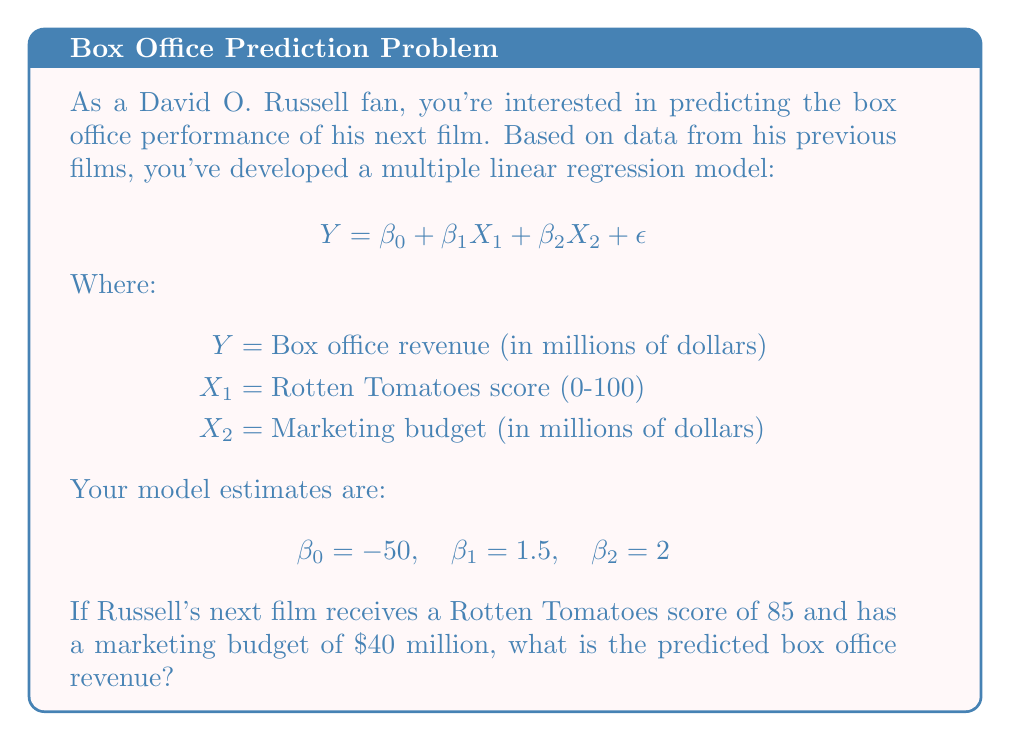Show me your answer to this math problem. To solve this problem, we'll use the given multiple linear regression model and substitute the known values:

1. Recall the model equation:
   $$Y = \beta_0 + \beta_1X_1 + \beta_2X_2 + \epsilon$$

2. We're given the following estimates:
   $\beta_0 = -50$
   $\beta_1 = 1.5$
   $\beta_2 = 2$

3. We're also given the values for the predictor variables:
   $X_1$ (Rotten Tomatoes score) = 85
   $X_2$ (Marketing budget) = 40

4. Let's substitute these values into the equation:
   $$Y = -50 + 1.5(85) + 2(40) + \epsilon$$

5. Simplify:
   $$Y = -50 + 127.5 + 80 + \epsilon$$
   $$Y = 157.5 + \epsilon$$

6. In prediction, we typically ignore the error term $\epsilon$, as it represents the unexplained variation. So our final prediction is:
   $$Y = 157.5$$

Therefore, the predicted box office revenue for David O. Russell's next film is $157.5 million.
Answer: $157.5 million 